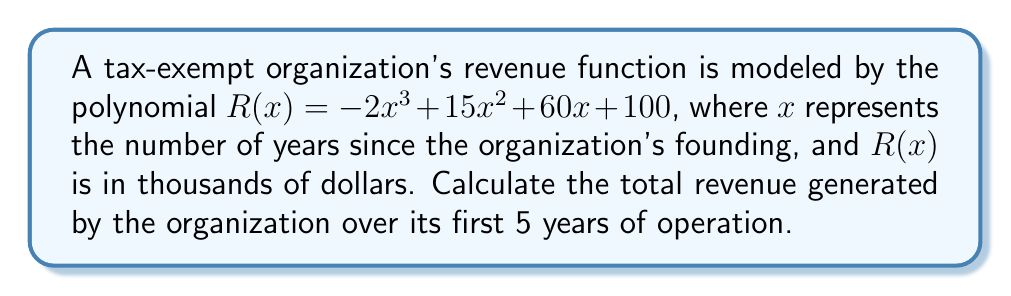Can you solve this math problem? To calculate the total revenue over the first 5 years, we need to find the sum of the revenues for each year from 0 to 4 (since the first year is represented by x = 0).

1) Calculate revenue for each year:
   Year 0 (founding): $R(0) = -2(0)^3 + 15(0)^2 + 60(0) + 100 = 100$
   Year 1: $R(1) = -2(1)^3 + 15(1)^2 + 60(1) + 100 = -2 + 15 + 60 + 100 = 173$
   Year 2: $R(2) = -2(2)^3 + 15(2)^2 + 60(2) + 100 = -16 + 60 + 120 + 100 = 264$
   Year 3: $R(3) = -2(3)^3 + 15(3)^2 + 60(3) + 100 = -54 + 135 + 180 + 100 = 361$
   Year 4: $R(4) = -2(4)^3 + 15(4)^2 + 60(4) + 100 = -128 + 240 + 240 + 100 = 452$

2) Sum up the revenues:
   Total Revenue = $R(0) + R(1) + R(2) + R(3) + R(4)$
                 = $100 + 173 + 264 + 361 + 452$
                 = $1350$

3) Convert to actual dollars:
   Since $R(x)$ is in thousands of dollars, multiply by 1000:
   $1350 * 1000 = 1,350,000$

Therefore, the total revenue over the first 5 years is $1,350,000.
Answer: $1,350,000 